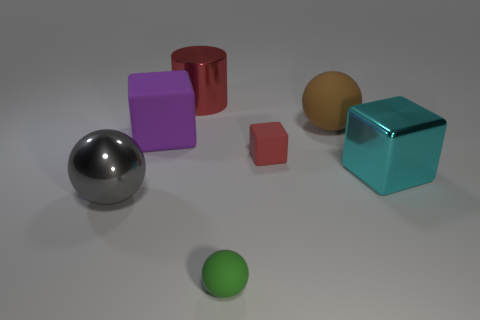There is a brown object that is the same size as the cylinder; what material is it? The brown object in the image appears to have a matte surface similar to clay or unglazed ceramic, commonly used in art or pottery. 